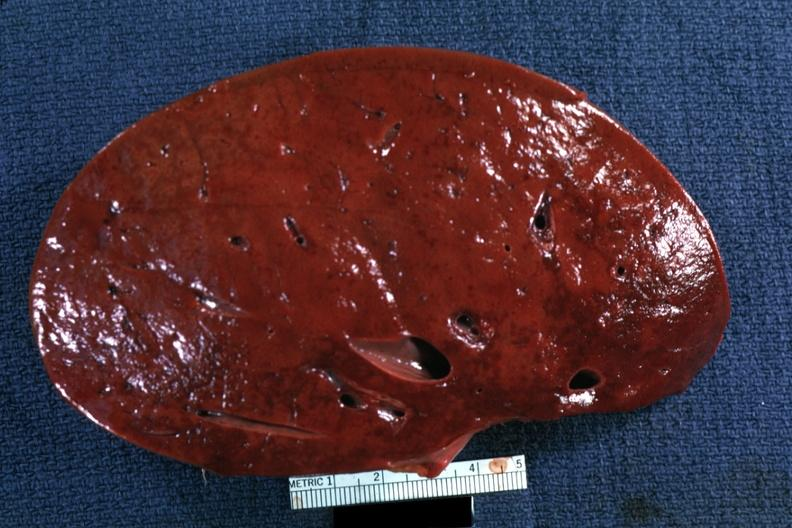s fibroma present?
Answer the question using a single word or phrase. No 